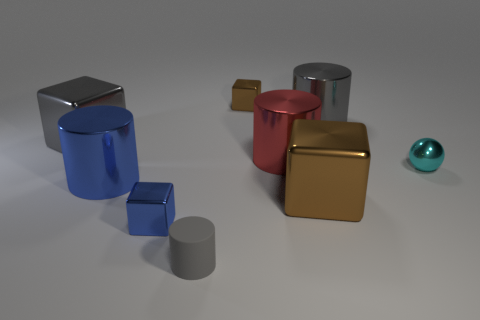Is there a red object that is behind the large gray shiny object on the right side of the gray metal block?
Your answer should be very brief. No. What number of gray objects are in front of the cylinder that is behind the large gray metal thing to the left of the gray rubber cylinder?
Your answer should be compact. 2. Is the number of tiny cyan metal things less than the number of metallic cylinders?
Offer a terse response. Yes. Do the brown object that is to the left of the red metal thing and the brown metal thing that is in front of the small cyan shiny sphere have the same shape?
Give a very brief answer. Yes. What color is the rubber cylinder?
Your response must be concise. Gray. How many shiny objects are either large brown things or large cubes?
Your answer should be very brief. 2. There is another matte object that is the same shape as the large blue object; what is its color?
Your response must be concise. Gray. Are there any large brown objects?
Provide a short and direct response. Yes. Do the brown thing that is behind the small metal ball and the cylinder that is in front of the blue block have the same material?
Keep it short and to the point. No. What number of objects are either large metal cylinders in front of the red cylinder or big things that are to the left of the gray shiny cylinder?
Provide a succinct answer. 4. 